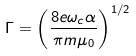<formula> <loc_0><loc_0><loc_500><loc_500>\Gamma = \left ( \frac { 8 e \omega _ { c } \alpha } { \pi m \mu _ { 0 } } \right ) ^ { 1 / 2 }</formula> 